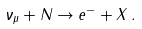Convert formula to latex. <formula><loc_0><loc_0><loc_500><loc_500>\nu _ { \mu } + N \to e ^ { - } + X \, .</formula> 